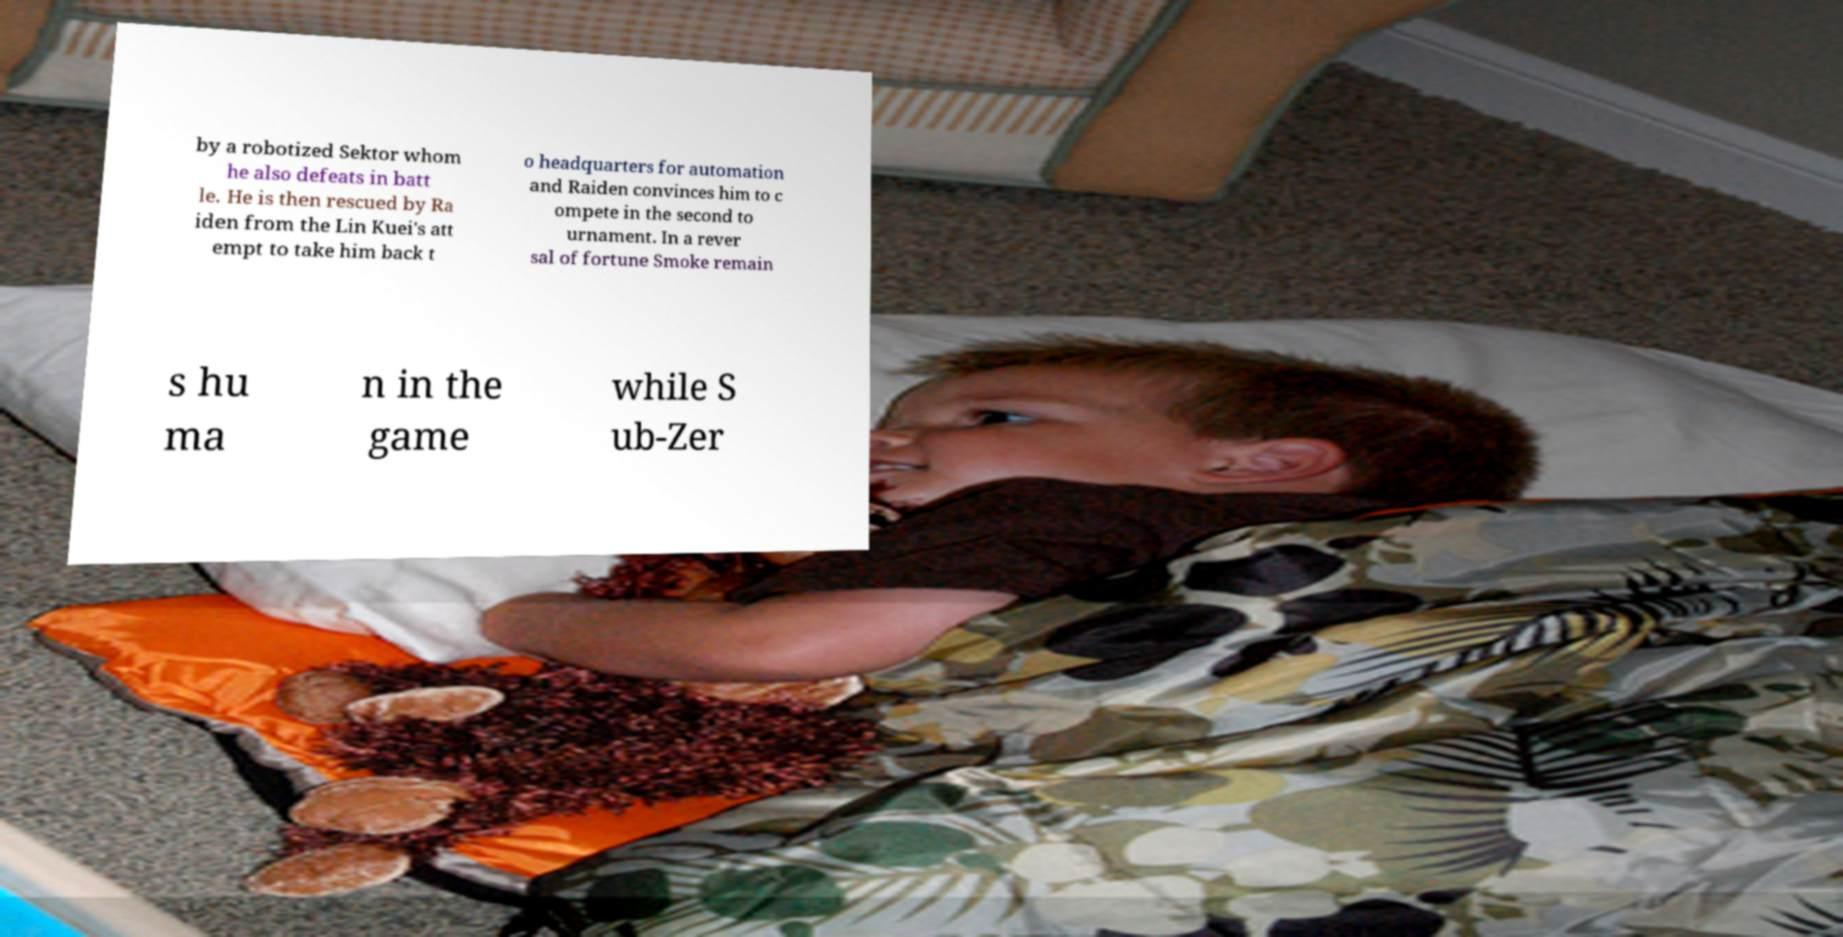Please identify and transcribe the text found in this image. by a robotized Sektor whom he also defeats in batt le. He is then rescued by Ra iden from the Lin Kuei's att empt to take him back t o headquarters for automation and Raiden convinces him to c ompete in the second to urnament. In a rever sal of fortune Smoke remain s hu ma n in the game while S ub-Zer 